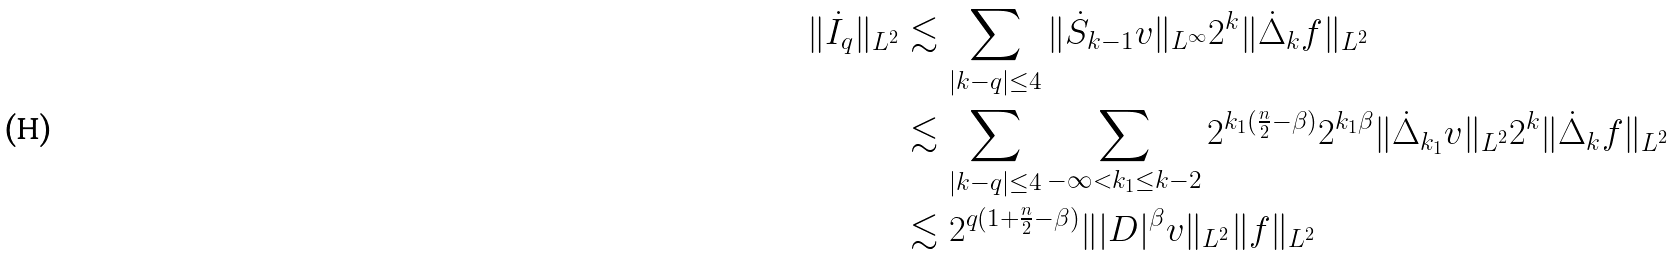<formula> <loc_0><loc_0><loc_500><loc_500>\| \dot { I } _ { q } \| _ { L ^ { 2 } } & \lesssim \sum _ { | k - q | \leq 4 } \| \dot { S } _ { k - 1 } v \| _ { L ^ { \infty } } 2 ^ { k } \| \dot { \Delta } _ { k } f \| _ { L ^ { 2 } } \\ & \lesssim \sum _ { | k - q | \leq 4 } \sum _ { - \infty < k _ { 1 } \leq k - 2 } 2 ^ { k _ { 1 } ( \frac { n } { 2 } - \beta ) } 2 ^ { k _ { 1 } \beta } \| \dot { \Delta } _ { k _ { 1 } } v \| _ { L ^ { 2 } } 2 ^ { k } \| \dot { \Delta } _ { k } f \| _ { L ^ { 2 } } \\ & \lesssim 2 ^ { q ( 1 + \frac { n } { 2 } - \beta ) } \| | D | ^ { \beta } v \| _ { L ^ { 2 } } \| f \| _ { L ^ { 2 } }</formula> 